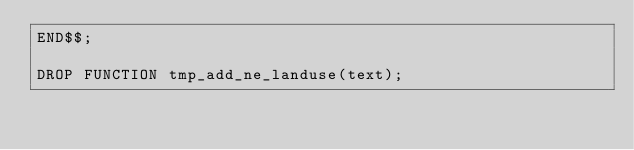<code> <loc_0><loc_0><loc_500><loc_500><_SQL_>END$$;

DROP FUNCTION tmp_add_ne_landuse(text);
</code> 